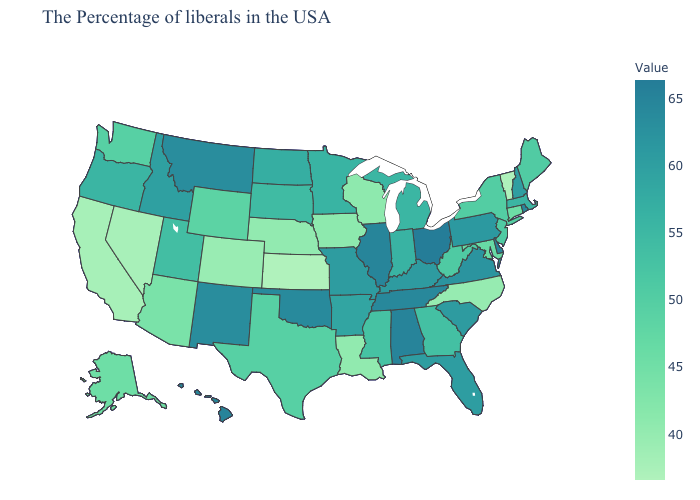Which states have the highest value in the USA?
Answer briefly. Ohio. Among the states that border Wyoming , which have the highest value?
Short answer required. Montana. Does Delaware have a higher value than South Dakota?
Keep it brief. Yes. Does Indiana have the lowest value in the MidWest?
Short answer required. No. 